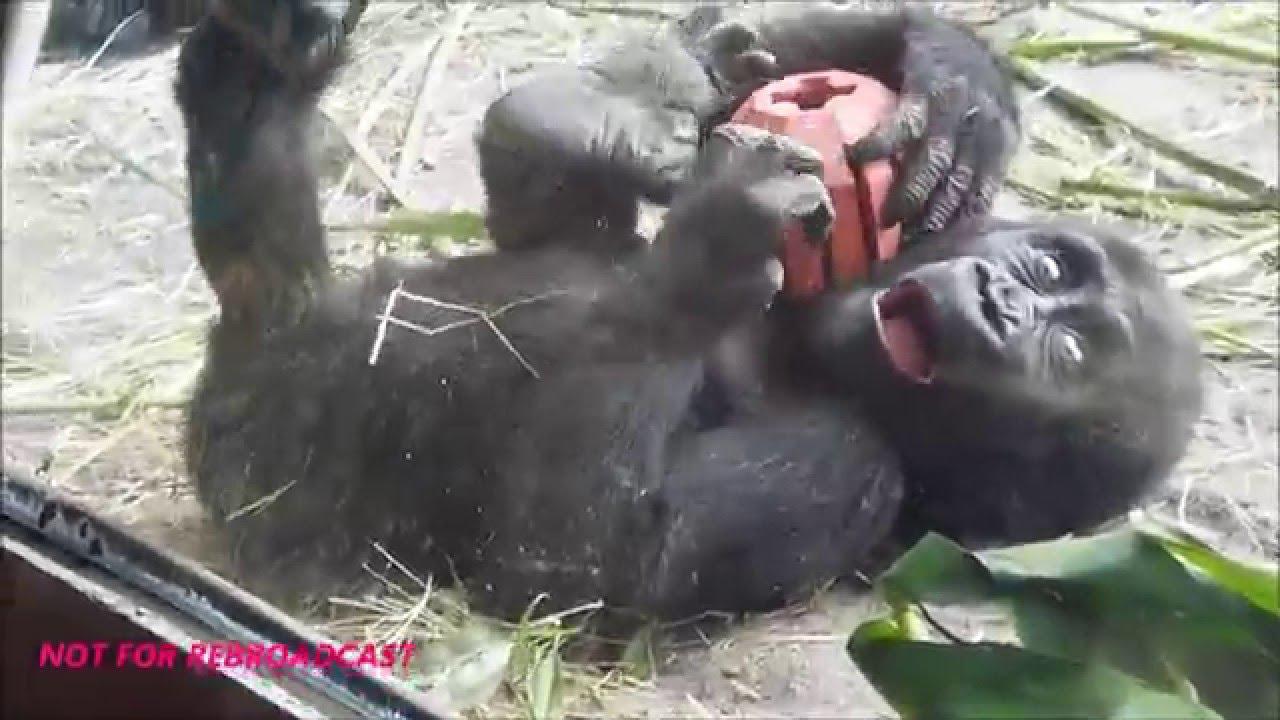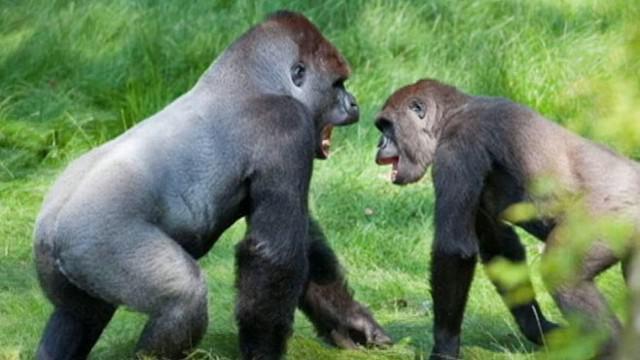The first image is the image on the left, the second image is the image on the right. For the images displayed, is the sentence "A primate is holding a ball in one of the images." factually correct? Answer yes or no. Yes. The first image is the image on the left, the second image is the image on the right. Evaluate the accuracy of this statement regarding the images: "A gorilla is holding onto something round and manmade, with a cross-shape on it.". Is it true? Answer yes or no. Yes. 